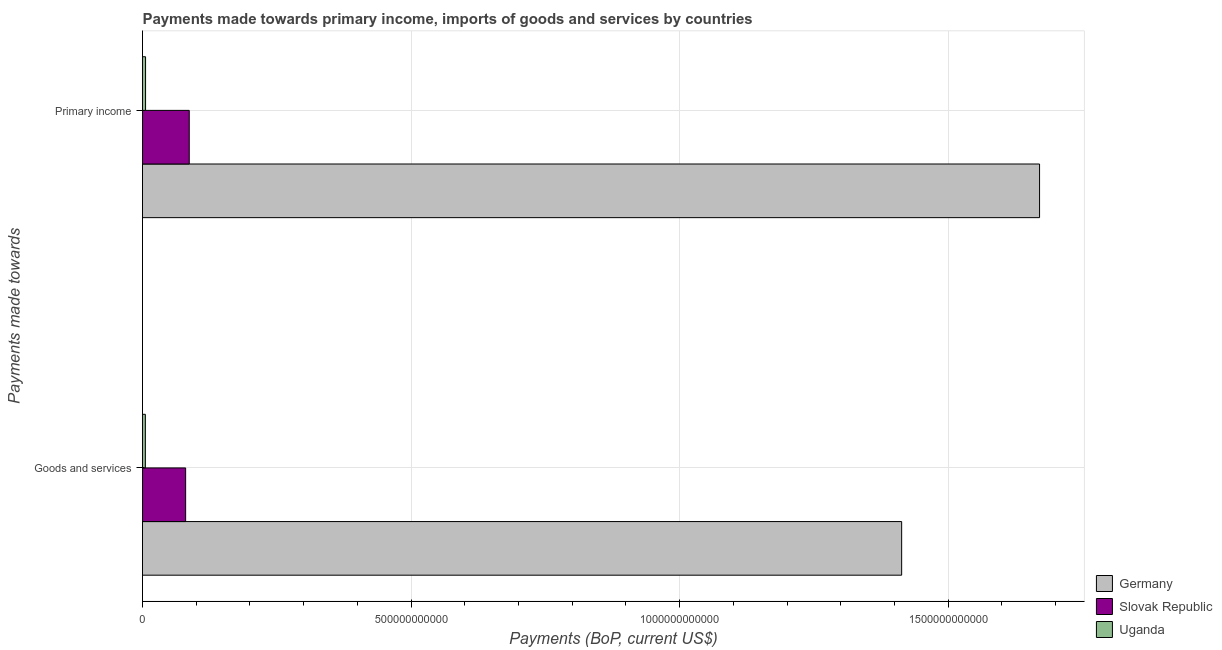How many different coloured bars are there?
Make the answer very short. 3. How many bars are there on the 2nd tick from the bottom?
Give a very brief answer. 3. What is the label of the 2nd group of bars from the top?
Your response must be concise. Goods and services. What is the payments made towards goods and services in Uganda?
Offer a very short reply. 5.30e+09. Across all countries, what is the maximum payments made towards goods and services?
Your response must be concise. 1.41e+12. Across all countries, what is the minimum payments made towards goods and services?
Your response must be concise. 5.30e+09. In which country was the payments made towards goods and services minimum?
Your answer should be very brief. Uganda. What is the total payments made towards primary income in the graph?
Provide a succinct answer. 1.76e+12. What is the difference between the payments made towards goods and services in Slovak Republic and that in Uganda?
Give a very brief answer. 7.50e+1. What is the difference between the payments made towards primary income in Uganda and the payments made towards goods and services in Germany?
Offer a terse response. -1.41e+12. What is the average payments made towards primary income per country?
Your answer should be compact. 5.88e+11. What is the difference between the payments made towards primary income and payments made towards goods and services in Germany?
Ensure brevity in your answer.  2.57e+11. In how many countries, is the payments made towards primary income greater than 1200000000000 US$?
Your response must be concise. 1. What is the ratio of the payments made towards goods and services in Slovak Republic to that in Uganda?
Give a very brief answer. 15.15. In how many countries, is the payments made towards primary income greater than the average payments made towards primary income taken over all countries?
Your answer should be compact. 1. What does the 2nd bar from the top in Goods and services represents?
Offer a very short reply. Slovak Republic. What does the 1st bar from the bottom in Goods and services represents?
Provide a succinct answer. Germany. How many countries are there in the graph?
Provide a succinct answer. 3. What is the difference between two consecutive major ticks on the X-axis?
Offer a terse response. 5.00e+11. Does the graph contain any zero values?
Your answer should be very brief. No. Does the graph contain grids?
Your answer should be compact. Yes. How are the legend labels stacked?
Ensure brevity in your answer.  Vertical. What is the title of the graph?
Ensure brevity in your answer.  Payments made towards primary income, imports of goods and services by countries. What is the label or title of the X-axis?
Your response must be concise. Payments (BoP, current US$). What is the label or title of the Y-axis?
Provide a short and direct response. Payments made towards. What is the Payments (BoP, current US$) of Germany in Goods and services?
Ensure brevity in your answer.  1.41e+12. What is the Payments (BoP, current US$) in Slovak Republic in Goods and services?
Offer a very short reply. 8.03e+1. What is the Payments (BoP, current US$) of Uganda in Goods and services?
Make the answer very short. 5.30e+09. What is the Payments (BoP, current US$) in Germany in Primary income?
Give a very brief answer. 1.67e+12. What is the Payments (BoP, current US$) in Slovak Republic in Primary income?
Give a very brief answer. 8.70e+1. What is the Payments (BoP, current US$) of Uganda in Primary income?
Provide a short and direct response. 5.68e+09. Across all Payments made towards, what is the maximum Payments (BoP, current US$) of Germany?
Your answer should be very brief. 1.67e+12. Across all Payments made towards, what is the maximum Payments (BoP, current US$) of Slovak Republic?
Offer a very short reply. 8.70e+1. Across all Payments made towards, what is the maximum Payments (BoP, current US$) in Uganda?
Your answer should be compact. 5.68e+09. Across all Payments made towards, what is the minimum Payments (BoP, current US$) of Germany?
Provide a short and direct response. 1.41e+12. Across all Payments made towards, what is the minimum Payments (BoP, current US$) in Slovak Republic?
Give a very brief answer. 8.03e+1. Across all Payments made towards, what is the minimum Payments (BoP, current US$) in Uganda?
Give a very brief answer. 5.30e+09. What is the total Payments (BoP, current US$) in Germany in the graph?
Your answer should be compact. 3.08e+12. What is the total Payments (BoP, current US$) of Slovak Republic in the graph?
Your answer should be very brief. 1.67e+11. What is the total Payments (BoP, current US$) of Uganda in the graph?
Your response must be concise. 1.10e+1. What is the difference between the Payments (BoP, current US$) in Germany in Goods and services and that in Primary income?
Offer a terse response. -2.57e+11. What is the difference between the Payments (BoP, current US$) of Slovak Republic in Goods and services and that in Primary income?
Offer a very short reply. -6.74e+09. What is the difference between the Payments (BoP, current US$) in Uganda in Goods and services and that in Primary income?
Your response must be concise. -3.80e+08. What is the difference between the Payments (BoP, current US$) in Germany in Goods and services and the Payments (BoP, current US$) in Slovak Republic in Primary income?
Make the answer very short. 1.33e+12. What is the difference between the Payments (BoP, current US$) in Germany in Goods and services and the Payments (BoP, current US$) in Uganda in Primary income?
Your answer should be compact. 1.41e+12. What is the difference between the Payments (BoP, current US$) in Slovak Republic in Goods and services and the Payments (BoP, current US$) in Uganda in Primary income?
Keep it short and to the point. 7.46e+1. What is the average Payments (BoP, current US$) in Germany per Payments made towards?
Offer a very short reply. 1.54e+12. What is the average Payments (BoP, current US$) of Slovak Republic per Payments made towards?
Offer a terse response. 8.37e+1. What is the average Payments (BoP, current US$) of Uganda per Payments made towards?
Provide a short and direct response. 5.49e+09. What is the difference between the Payments (BoP, current US$) in Germany and Payments (BoP, current US$) in Slovak Republic in Goods and services?
Give a very brief answer. 1.33e+12. What is the difference between the Payments (BoP, current US$) of Germany and Payments (BoP, current US$) of Uganda in Goods and services?
Provide a short and direct response. 1.41e+12. What is the difference between the Payments (BoP, current US$) in Slovak Republic and Payments (BoP, current US$) in Uganda in Goods and services?
Offer a terse response. 7.50e+1. What is the difference between the Payments (BoP, current US$) of Germany and Payments (BoP, current US$) of Slovak Republic in Primary income?
Ensure brevity in your answer.  1.58e+12. What is the difference between the Payments (BoP, current US$) in Germany and Payments (BoP, current US$) in Uganda in Primary income?
Make the answer very short. 1.66e+12. What is the difference between the Payments (BoP, current US$) of Slovak Republic and Payments (BoP, current US$) of Uganda in Primary income?
Give a very brief answer. 8.14e+1. What is the ratio of the Payments (BoP, current US$) in Germany in Goods and services to that in Primary income?
Keep it short and to the point. 0.85. What is the ratio of the Payments (BoP, current US$) in Slovak Republic in Goods and services to that in Primary income?
Provide a succinct answer. 0.92. What is the ratio of the Payments (BoP, current US$) of Uganda in Goods and services to that in Primary income?
Your response must be concise. 0.93. What is the difference between the highest and the second highest Payments (BoP, current US$) of Germany?
Provide a short and direct response. 2.57e+11. What is the difference between the highest and the second highest Payments (BoP, current US$) of Slovak Republic?
Give a very brief answer. 6.74e+09. What is the difference between the highest and the second highest Payments (BoP, current US$) in Uganda?
Your response must be concise. 3.80e+08. What is the difference between the highest and the lowest Payments (BoP, current US$) of Germany?
Offer a terse response. 2.57e+11. What is the difference between the highest and the lowest Payments (BoP, current US$) of Slovak Republic?
Ensure brevity in your answer.  6.74e+09. What is the difference between the highest and the lowest Payments (BoP, current US$) in Uganda?
Offer a very short reply. 3.80e+08. 